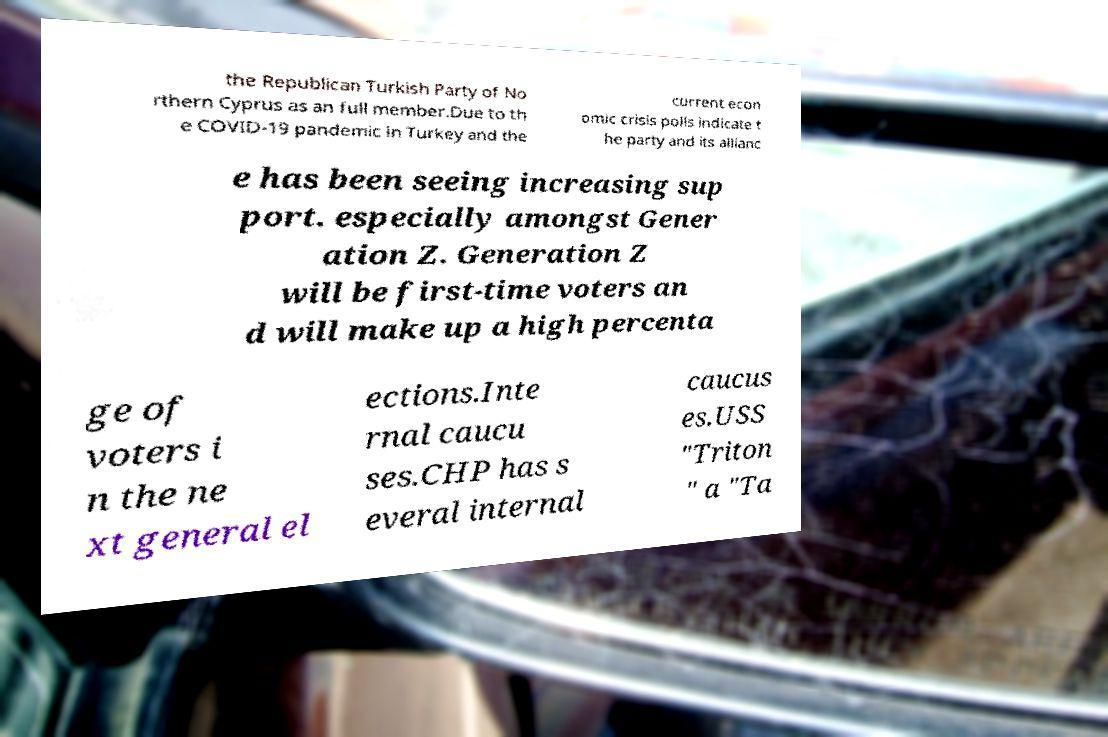For documentation purposes, I need the text within this image transcribed. Could you provide that? the Republican Turkish Party of No rthern Cyprus as an full member.Due to th e COVID-19 pandemic in Turkey and the current econ omic crisis polls indicate t he party and its allianc e has been seeing increasing sup port. especially amongst Gener ation Z. Generation Z will be first-time voters an d will make up a high percenta ge of voters i n the ne xt general el ections.Inte rnal caucu ses.CHP has s everal internal caucus es.USS "Triton " a "Ta 